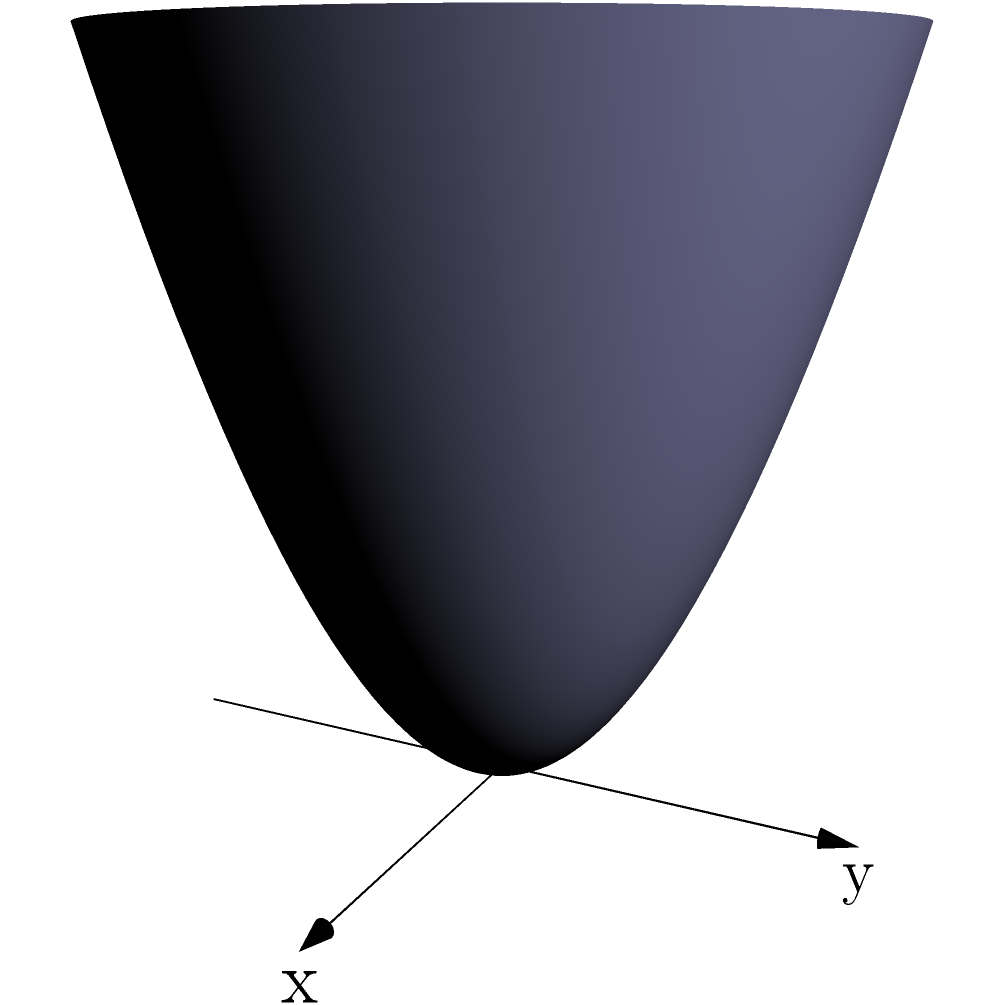Calculate the volume of the 3D shape shown in the figure, which is bounded by the surface $z = x^2 + y^2$ and the plane $z = 4$, using integral calculus. To calculate the volume of this irregular 3D shape, we'll use cylindrical coordinates and triple integration. Here's the step-by-step solution:

1) The surface is defined by $z = x^2 + y^2$, which in cylindrical coordinates becomes $z = r^2$.

2) The upper bound is the plane $z = 4$.

3) The volume is bounded radially from $r = 0$ to where $r^2 = 4$, i.e., $r = 2$.

4) The angle $\theta$ goes from 0 to $2\pi$.

5) The triple integral for the volume is:

   $$V = \int_0^{2\pi} \int_0^2 \int_{r^2}^4 r \, dz \, dr \, d\theta$$

6) Evaluate the inner integral:

   $$V = \int_0^{2\pi} \int_0^2 r(4 - r^2) \, dr \, d\theta$$

7) Evaluate the middle integral:

   $$V = \int_0^{2\pi} \left[2r^2 - \frac{r^4}{4}\right]_0^2 \, d\theta$$
   $$V = \int_0^{2\pi} (8 - 4) \, d\theta = \int_0^{2\pi} 4 \, d\theta$$

8) Evaluate the outer integral:

   $$V = 4 \cdot 2\pi = 8\pi$$

Therefore, the volume of the 3D shape is $8\pi$ cubic units.
Answer: $8\pi$ cubic units 